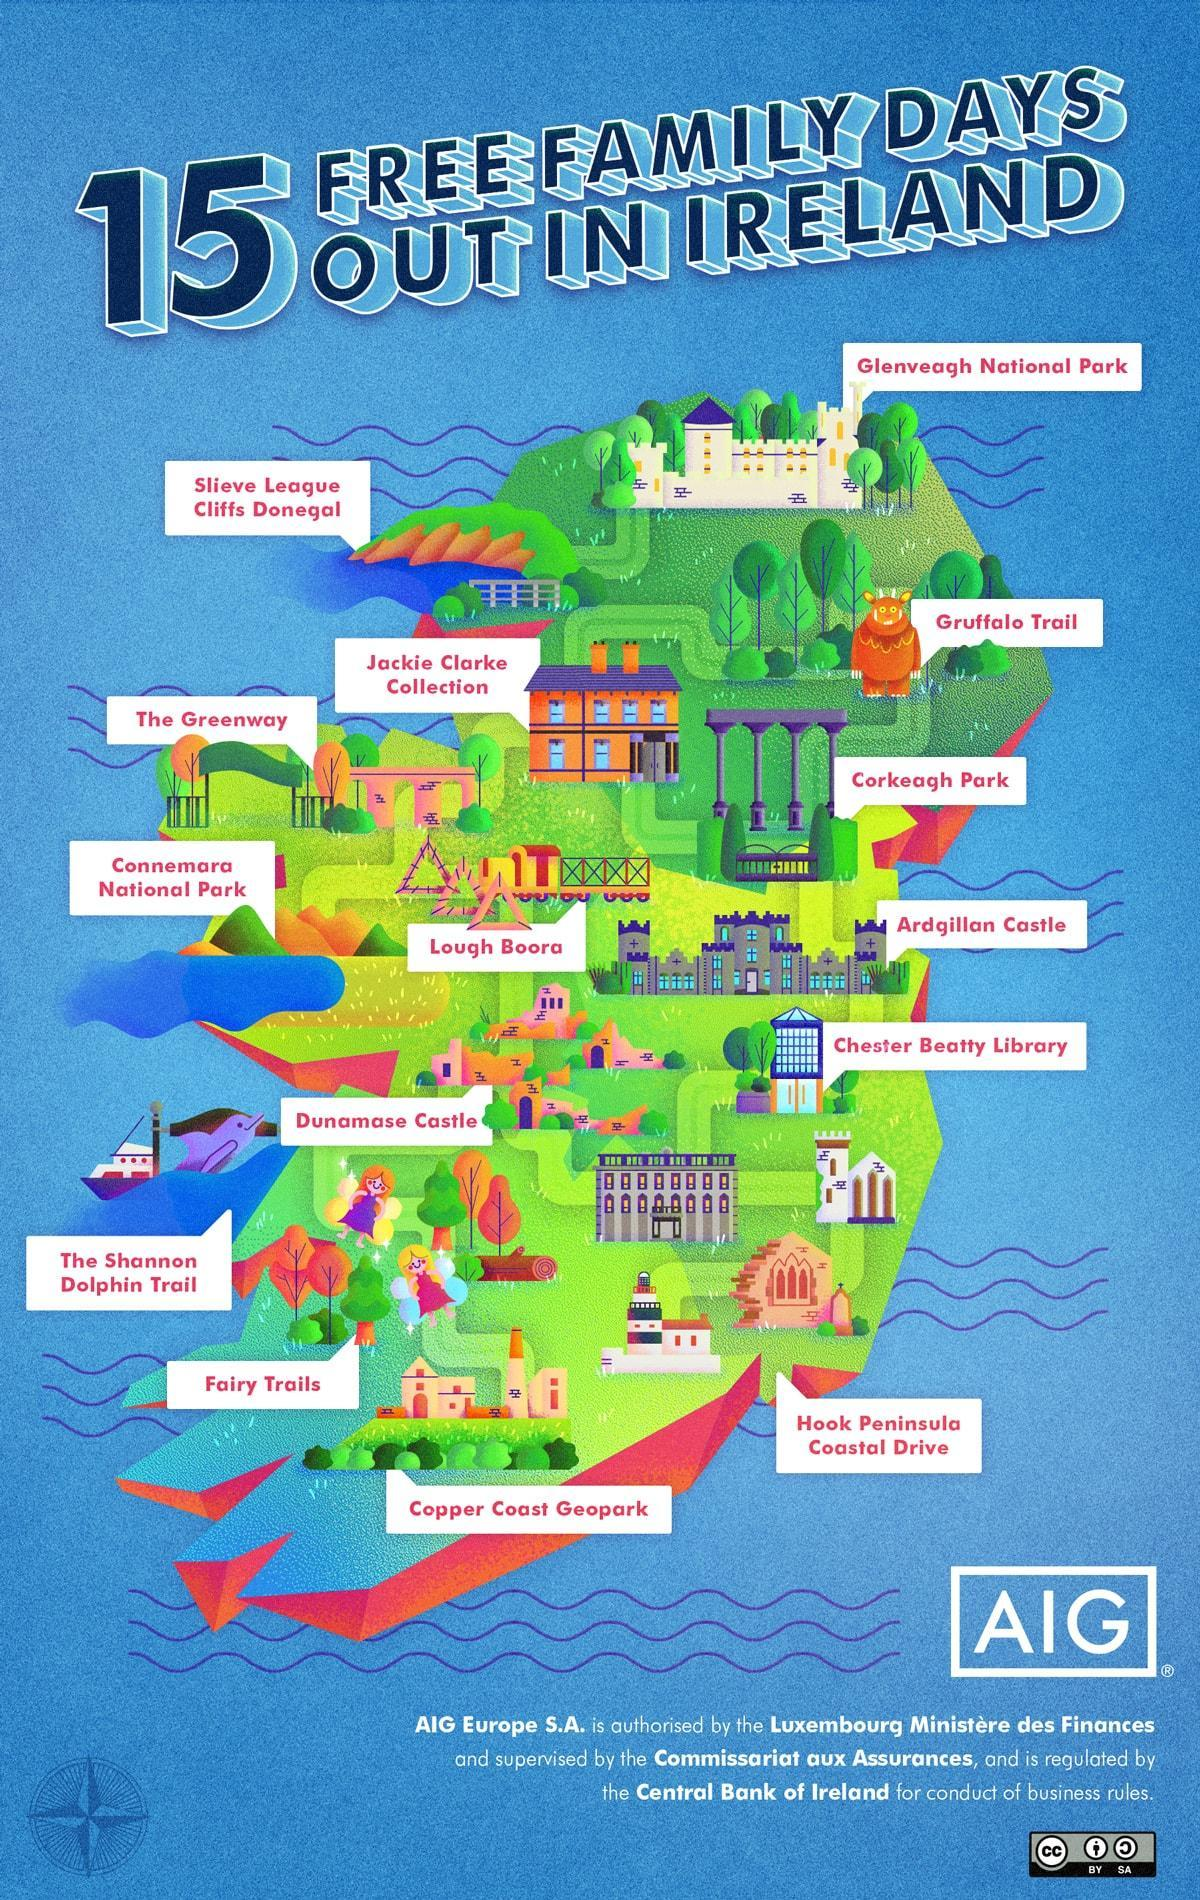How many national parks are in Ireland?
Answer the question with a short phrase. 2 How many parks are in Ireland? 4 How many trails are in Ireland? 3 